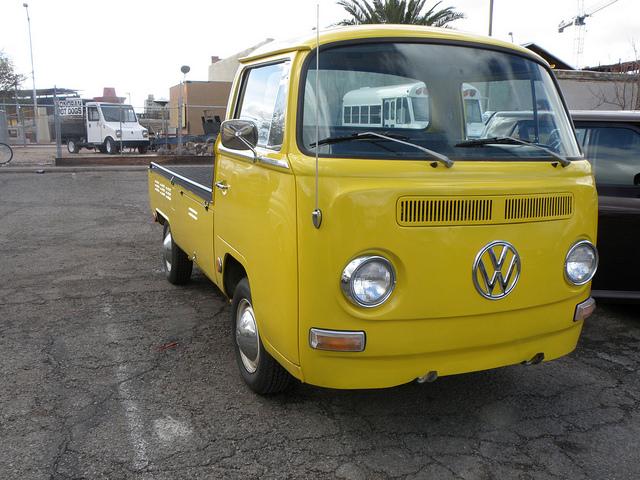What brand is this truck?
Quick response, please. Volkswagen. What color is the truck?
Concise answer only. Yellow. What type of tree is behind the truck?
Be succinct. Palm. 